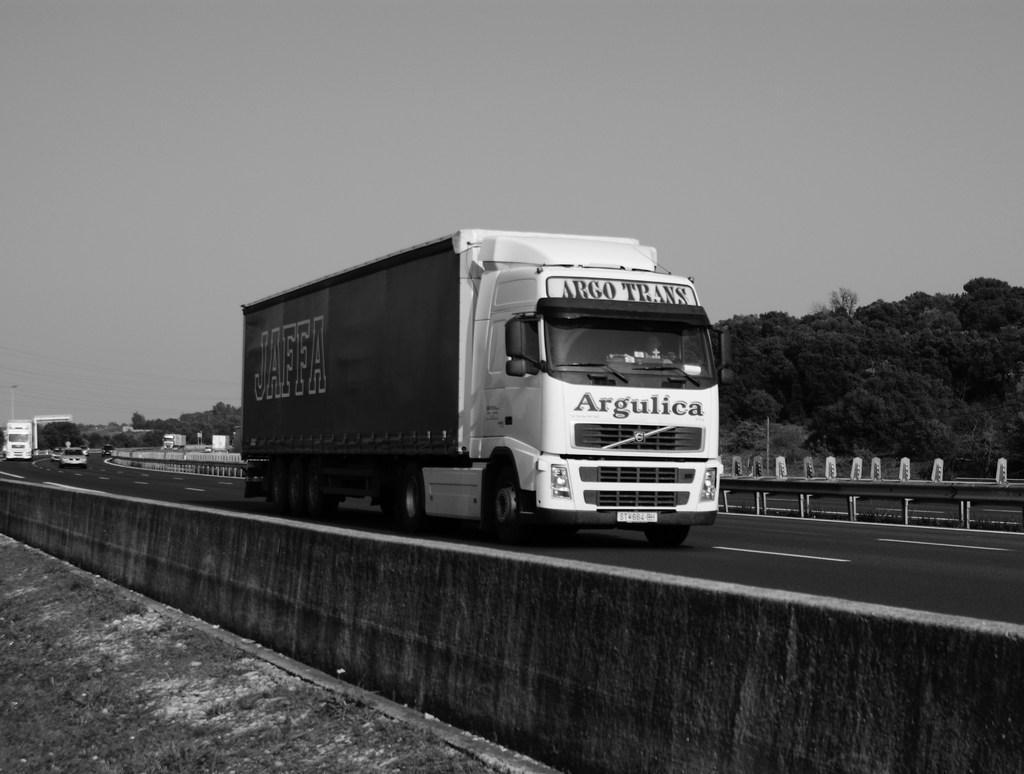Please provide a concise description of this image. In this image I can see few vehicles on the road. Back I can see few trees and fencing. The image is in black and white. 